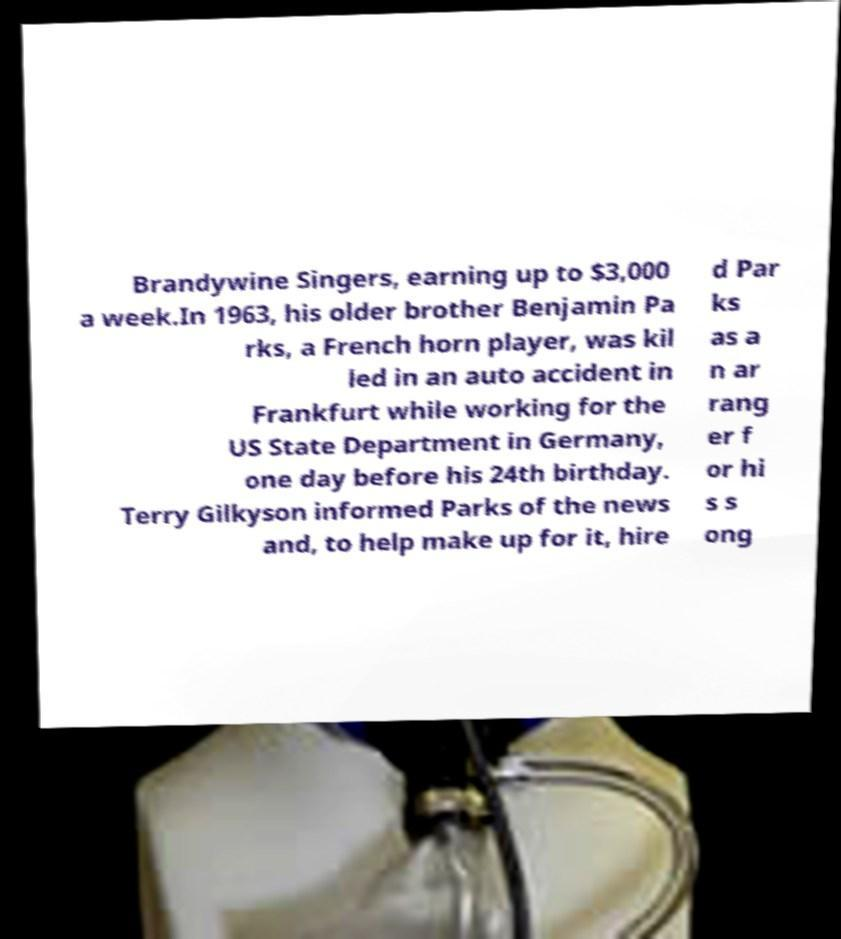Can you read and provide the text displayed in the image?This photo seems to have some interesting text. Can you extract and type it out for me? Brandywine Singers, earning up to $3,000 a week.In 1963, his older brother Benjamin Pa rks, a French horn player, was kil led in an auto accident in Frankfurt while working for the US State Department in Germany, one day before his 24th birthday. Terry Gilkyson informed Parks of the news and, to help make up for it, hire d Par ks as a n ar rang er f or hi s s ong 